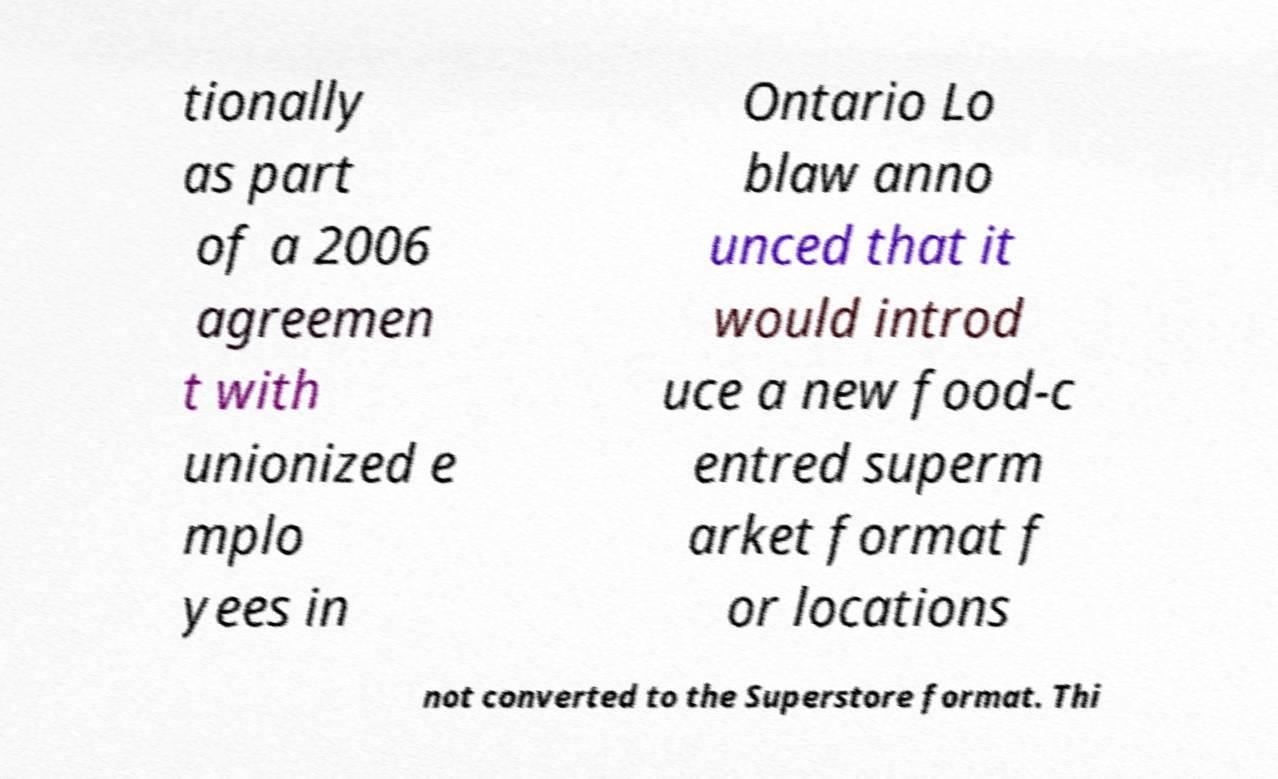Could you extract and type out the text from this image? tionally as part of a 2006 agreemen t with unionized e mplo yees in Ontario Lo blaw anno unced that it would introd uce a new food-c entred superm arket format f or locations not converted to the Superstore format. Thi 